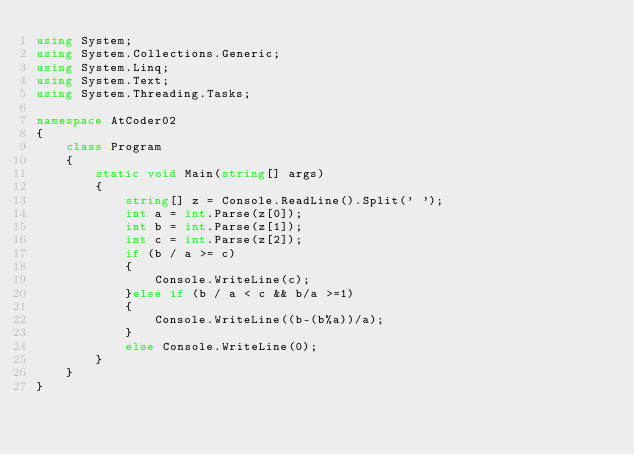Convert code to text. <code><loc_0><loc_0><loc_500><loc_500><_C#_>using System;
using System.Collections.Generic;
using System.Linq;
using System.Text;
using System.Threading.Tasks;

namespace AtCoder02
{
    class Program
    {
        static void Main(string[] args)
        {
            string[] z = Console.ReadLine().Split(' ');
            int a = int.Parse(z[0]);
            int b = int.Parse(z[1]);
            int c = int.Parse(z[2]);
            if (b / a >= c)
            {
                Console.WriteLine(c);
            }else if (b / a < c && b/a >=1)
            {
                Console.WriteLine((b-(b%a))/a);
            }
            else Console.WriteLine(0);
        }
    }
}</code> 